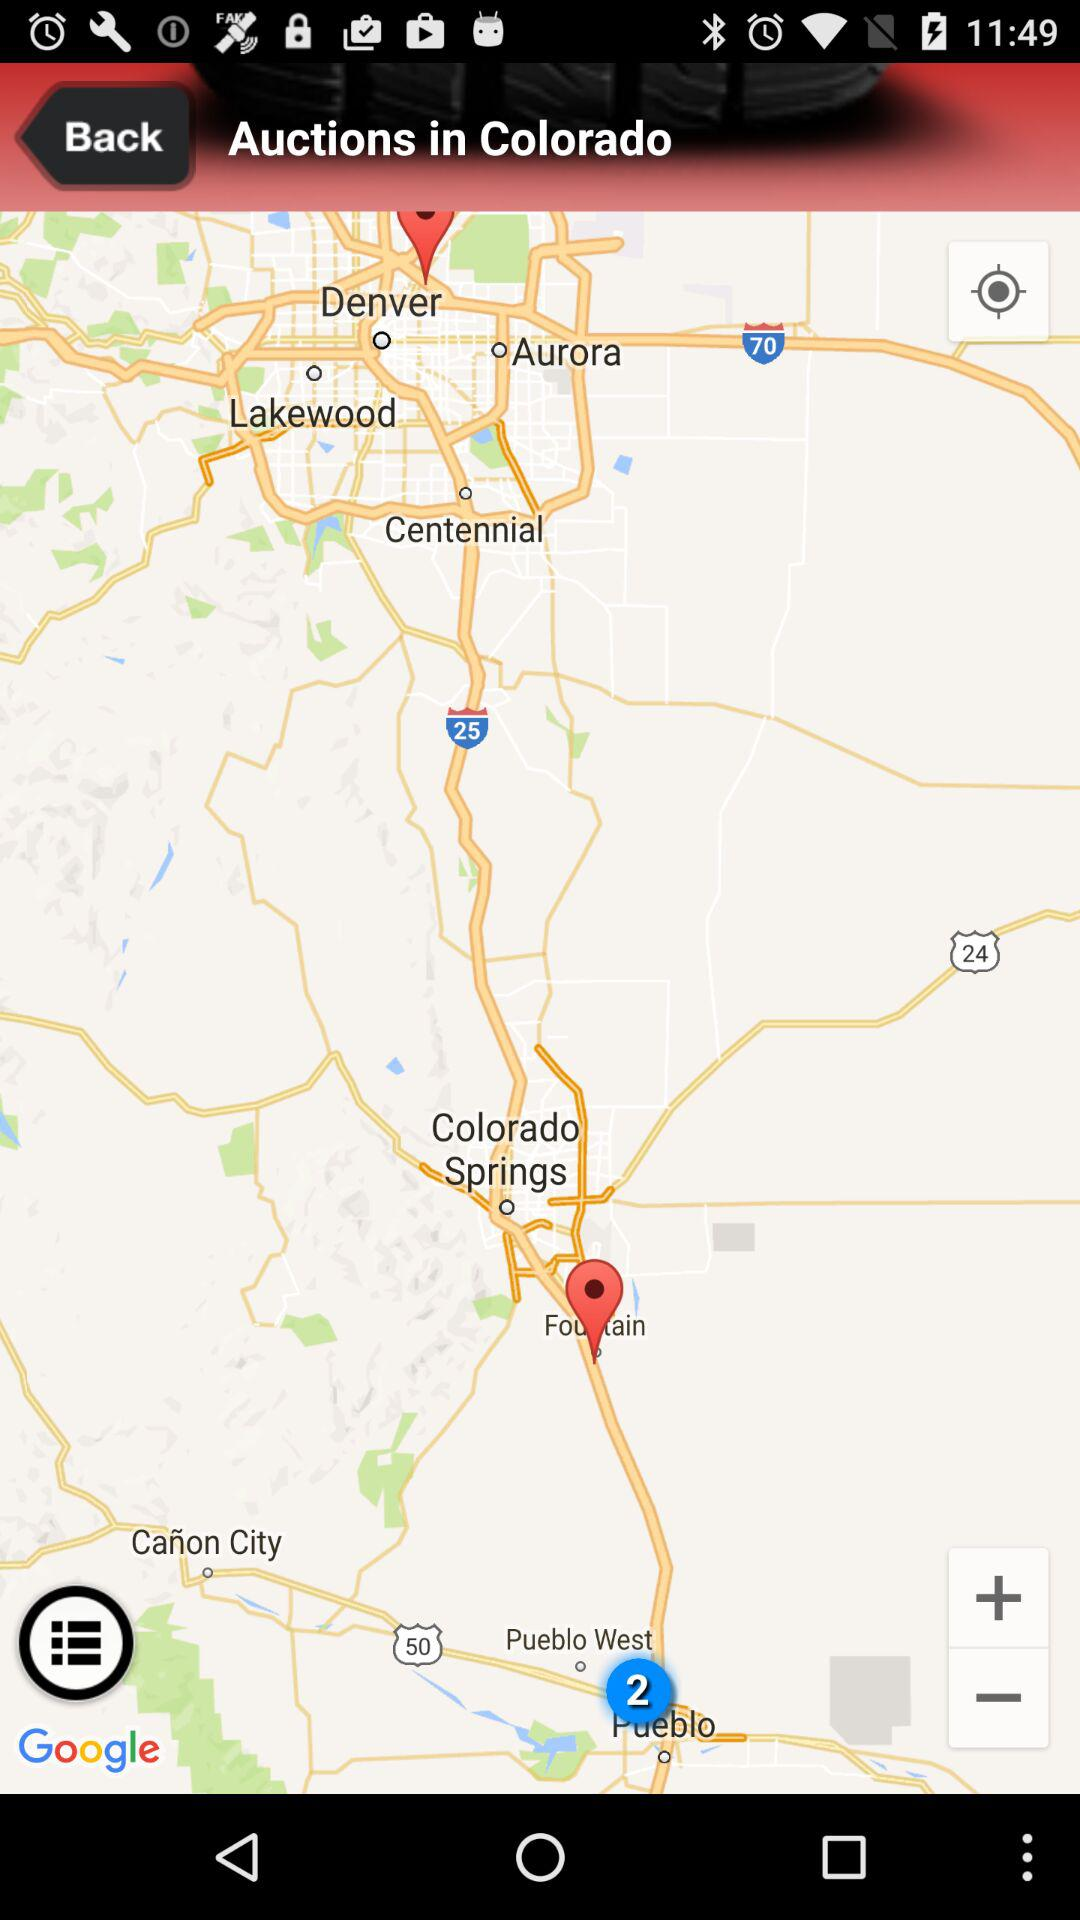What is the location? The location is Colorado. 